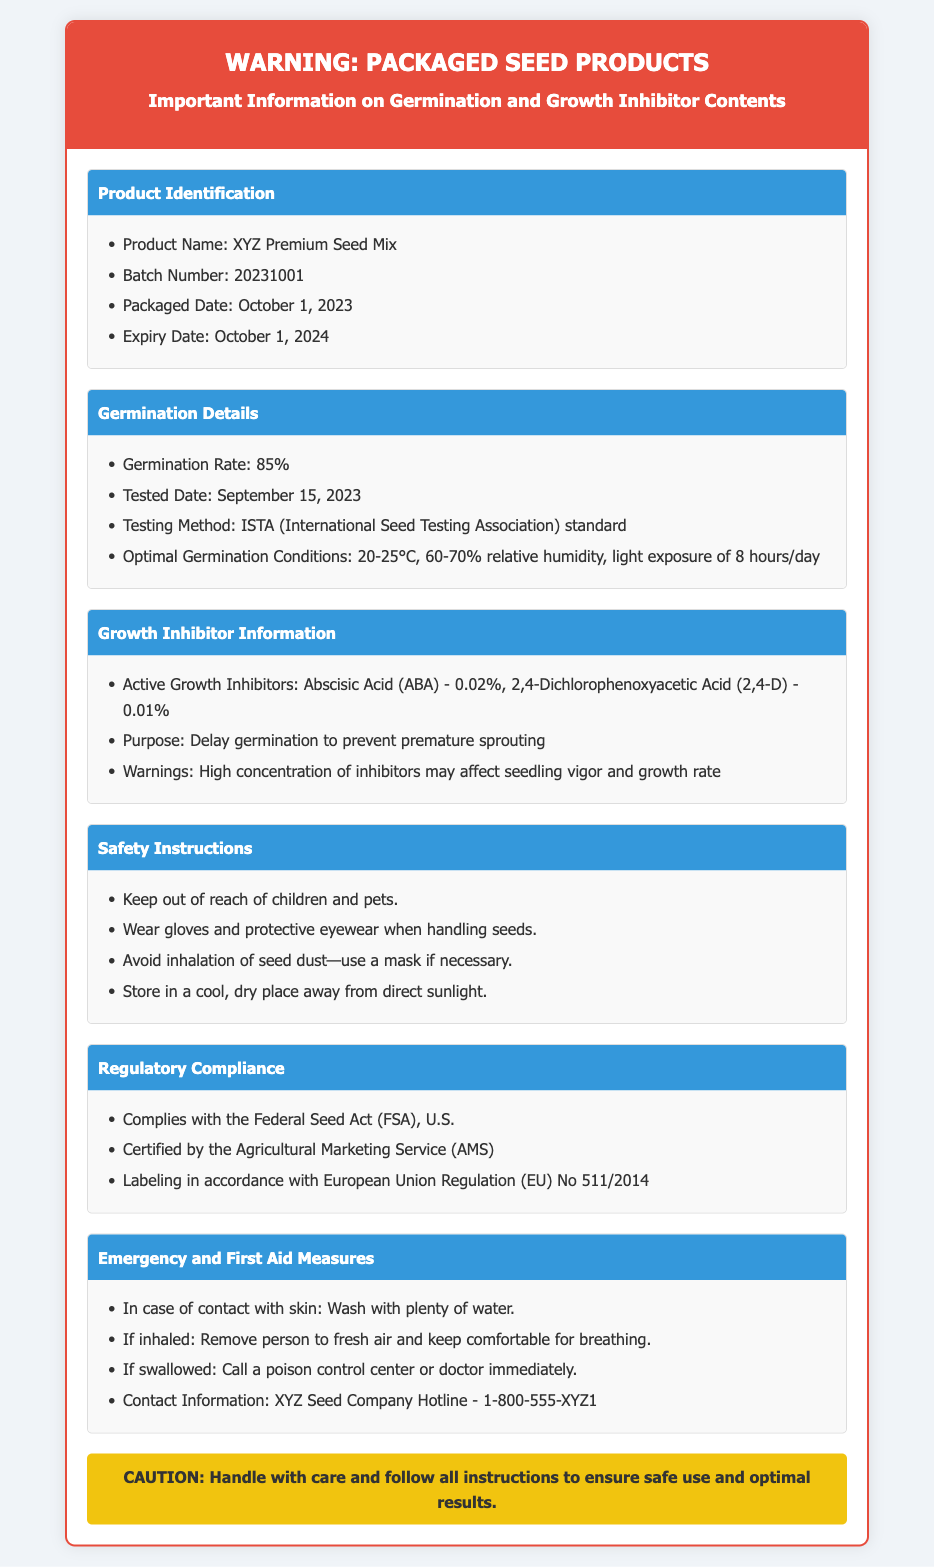What is the product name? The product name is stated in the Product Identification section of the document.
Answer: XYZ Premium Seed Mix What is the germination rate? The germination rate is mentioned in the Germination Details section of the document.
Answer: 85% What is the batch number? The batch number is part of the Product Identification details in the document.
Answer: 20231001 What is the expiry date? The expiry date is listed in the Product Identification section of the document.
Answer: October 1, 2024 What are the active growth inhibitors? The active growth inhibitors are specified in the Growth Inhibitor Information section of the document.
Answer: Abscisic Acid (ABA) - 0.02%, 2,4-Dichlorophenoxyacetic Acid (2,4-D) - 0.01% Why are growth inhibitors used? The purpose of growth inhibitors is explained in the Growth Inhibitor Information section.
Answer: Delay germination to prevent premature sprouting What is the testing method for germination? The testing method is detailed in the Germination Details section of the document.
Answer: ISTA (International Seed Testing Association) standard What should you do if seeds are inhaled? Emergency and First Aid Measures section describes this scenario.
Answer: Remove person to fresh air and keep comfortable for breathing What is the compliance with regards to the Federal Seed Act? Regulatory Compliance section states the product's adherence to the law.
Answer: Complies with the Federal Seed Act (FSA), U.S 